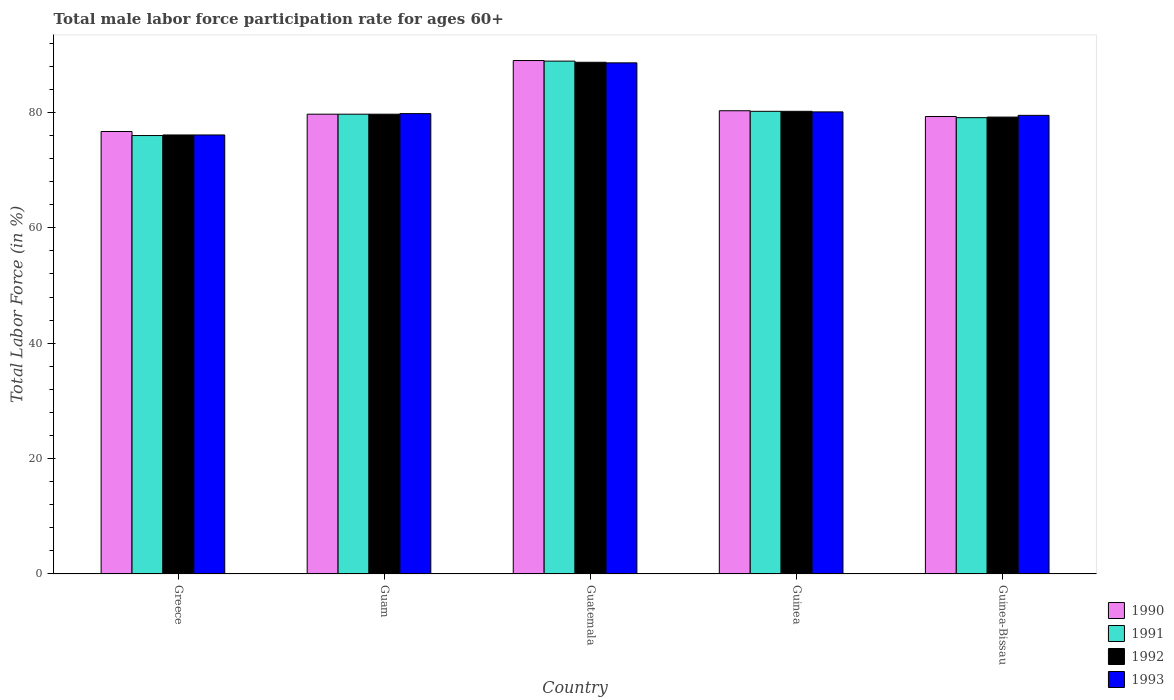How many different coloured bars are there?
Offer a terse response. 4. Are the number of bars per tick equal to the number of legend labels?
Your answer should be very brief. Yes. What is the label of the 5th group of bars from the left?
Give a very brief answer. Guinea-Bissau. What is the male labor force participation rate in 1992 in Guinea-Bissau?
Ensure brevity in your answer.  79.2. Across all countries, what is the maximum male labor force participation rate in 1991?
Provide a short and direct response. 88.9. Across all countries, what is the minimum male labor force participation rate in 1993?
Your answer should be compact. 76.1. In which country was the male labor force participation rate in 1990 maximum?
Offer a very short reply. Guatemala. In which country was the male labor force participation rate in 1990 minimum?
Provide a short and direct response. Greece. What is the total male labor force participation rate in 1992 in the graph?
Your answer should be very brief. 403.9. What is the difference between the male labor force participation rate in 1992 in Greece and that in Guinea-Bissau?
Your answer should be very brief. -3.1. What is the difference between the male labor force participation rate in 1991 in Greece and the male labor force participation rate in 1992 in Guinea-Bissau?
Make the answer very short. -3.2. What is the difference between the male labor force participation rate of/in 1993 and male labor force participation rate of/in 1991 in Guatemala?
Ensure brevity in your answer.  -0.3. What is the ratio of the male labor force participation rate in 1993 in Greece to that in Guinea?
Give a very brief answer. 0.95. Is the male labor force participation rate in 1993 in Guatemala less than that in Guinea?
Offer a very short reply. No. What is the difference between the highest and the second highest male labor force participation rate in 1991?
Ensure brevity in your answer.  8.7. What is the difference between the highest and the lowest male labor force participation rate in 1993?
Your answer should be very brief. 12.5. Is the sum of the male labor force participation rate in 1993 in Greece and Guinea-Bissau greater than the maximum male labor force participation rate in 1991 across all countries?
Make the answer very short. Yes. Is it the case that in every country, the sum of the male labor force participation rate in 1990 and male labor force participation rate in 1992 is greater than the sum of male labor force participation rate in 1993 and male labor force participation rate in 1991?
Your response must be concise. No. How many bars are there?
Provide a short and direct response. 20. How many countries are there in the graph?
Ensure brevity in your answer.  5. How are the legend labels stacked?
Offer a very short reply. Vertical. What is the title of the graph?
Offer a very short reply. Total male labor force participation rate for ages 60+. Does "1963" appear as one of the legend labels in the graph?
Keep it short and to the point. No. What is the label or title of the X-axis?
Ensure brevity in your answer.  Country. What is the label or title of the Y-axis?
Offer a very short reply. Total Labor Force (in %). What is the Total Labor Force (in %) of 1990 in Greece?
Your response must be concise. 76.7. What is the Total Labor Force (in %) in 1992 in Greece?
Give a very brief answer. 76.1. What is the Total Labor Force (in %) in 1993 in Greece?
Give a very brief answer. 76.1. What is the Total Labor Force (in %) in 1990 in Guam?
Give a very brief answer. 79.7. What is the Total Labor Force (in %) of 1991 in Guam?
Provide a succinct answer. 79.7. What is the Total Labor Force (in %) of 1992 in Guam?
Make the answer very short. 79.7. What is the Total Labor Force (in %) of 1993 in Guam?
Your response must be concise. 79.8. What is the Total Labor Force (in %) in 1990 in Guatemala?
Your answer should be very brief. 89. What is the Total Labor Force (in %) of 1991 in Guatemala?
Your response must be concise. 88.9. What is the Total Labor Force (in %) of 1992 in Guatemala?
Keep it short and to the point. 88.7. What is the Total Labor Force (in %) in 1993 in Guatemala?
Keep it short and to the point. 88.6. What is the Total Labor Force (in %) of 1990 in Guinea?
Provide a succinct answer. 80.3. What is the Total Labor Force (in %) of 1991 in Guinea?
Your answer should be compact. 80.2. What is the Total Labor Force (in %) of 1992 in Guinea?
Your response must be concise. 80.2. What is the Total Labor Force (in %) in 1993 in Guinea?
Your answer should be very brief. 80.1. What is the Total Labor Force (in %) in 1990 in Guinea-Bissau?
Make the answer very short. 79.3. What is the Total Labor Force (in %) of 1991 in Guinea-Bissau?
Ensure brevity in your answer.  79.1. What is the Total Labor Force (in %) in 1992 in Guinea-Bissau?
Your answer should be very brief. 79.2. What is the Total Labor Force (in %) of 1993 in Guinea-Bissau?
Your answer should be very brief. 79.5. Across all countries, what is the maximum Total Labor Force (in %) in 1990?
Offer a terse response. 89. Across all countries, what is the maximum Total Labor Force (in %) of 1991?
Offer a very short reply. 88.9. Across all countries, what is the maximum Total Labor Force (in %) in 1992?
Provide a succinct answer. 88.7. Across all countries, what is the maximum Total Labor Force (in %) in 1993?
Offer a terse response. 88.6. Across all countries, what is the minimum Total Labor Force (in %) of 1990?
Provide a succinct answer. 76.7. Across all countries, what is the minimum Total Labor Force (in %) in 1992?
Ensure brevity in your answer.  76.1. Across all countries, what is the minimum Total Labor Force (in %) of 1993?
Provide a short and direct response. 76.1. What is the total Total Labor Force (in %) in 1990 in the graph?
Offer a terse response. 405. What is the total Total Labor Force (in %) in 1991 in the graph?
Provide a short and direct response. 403.9. What is the total Total Labor Force (in %) in 1992 in the graph?
Give a very brief answer. 403.9. What is the total Total Labor Force (in %) of 1993 in the graph?
Keep it short and to the point. 404.1. What is the difference between the Total Labor Force (in %) of 1991 in Greece and that in Guam?
Give a very brief answer. -3.7. What is the difference between the Total Labor Force (in %) of 1993 in Greece and that in Guam?
Make the answer very short. -3.7. What is the difference between the Total Labor Force (in %) of 1992 in Greece and that in Guatemala?
Keep it short and to the point. -12.6. What is the difference between the Total Labor Force (in %) of 1993 in Greece and that in Guatemala?
Your response must be concise. -12.5. What is the difference between the Total Labor Force (in %) in 1990 in Greece and that in Guinea?
Offer a terse response. -3.6. What is the difference between the Total Labor Force (in %) in 1992 in Greece and that in Guinea?
Offer a terse response. -4.1. What is the difference between the Total Labor Force (in %) of 1990 in Greece and that in Guinea-Bissau?
Keep it short and to the point. -2.6. What is the difference between the Total Labor Force (in %) in 1993 in Greece and that in Guinea-Bissau?
Provide a succinct answer. -3.4. What is the difference between the Total Labor Force (in %) of 1991 in Guam and that in Guatemala?
Your response must be concise. -9.2. What is the difference between the Total Labor Force (in %) in 1992 in Guam and that in Guatemala?
Provide a succinct answer. -9. What is the difference between the Total Labor Force (in %) of 1993 in Guam and that in Guatemala?
Keep it short and to the point. -8.8. What is the difference between the Total Labor Force (in %) of 1990 in Guam and that in Guinea?
Your answer should be very brief. -0.6. What is the difference between the Total Labor Force (in %) of 1991 in Guam and that in Guinea?
Provide a short and direct response. -0.5. What is the difference between the Total Labor Force (in %) of 1992 in Guam and that in Guinea?
Give a very brief answer. -0.5. What is the difference between the Total Labor Force (in %) in 1993 in Guam and that in Guinea?
Give a very brief answer. -0.3. What is the difference between the Total Labor Force (in %) in 1992 in Guam and that in Guinea-Bissau?
Your answer should be very brief. 0.5. What is the difference between the Total Labor Force (in %) of 1993 in Guam and that in Guinea-Bissau?
Offer a terse response. 0.3. What is the difference between the Total Labor Force (in %) in 1990 in Guatemala and that in Guinea?
Your response must be concise. 8.7. What is the difference between the Total Labor Force (in %) in 1993 in Guatemala and that in Guinea?
Offer a terse response. 8.5. What is the difference between the Total Labor Force (in %) of 1990 in Guatemala and that in Guinea-Bissau?
Your answer should be very brief. 9.7. What is the difference between the Total Labor Force (in %) in 1991 in Guatemala and that in Guinea-Bissau?
Provide a short and direct response. 9.8. What is the difference between the Total Labor Force (in %) of 1992 in Guatemala and that in Guinea-Bissau?
Provide a short and direct response. 9.5. What is the difference between the Total Labor Force (in %) in 1990 in Guinea and that in Guinea-Bissau?
Your response must be concise. 1. What is the difference between the Total Labor Force (in %) in 1991 in Guinea and that in Guinea-Bissau?
Your answer should be compact. 1.1. What is the difference between the Total Labor Force (in %) in 1990 in Greece and the Total Labor Force (in %) in 1992 in Guam?
Give a very brief answer. -3. What is the difference between the Total Labor Force (in %) of 1990 in Greece and the Total Labor Force (in %) of 1991 in Guatemala?
Your answer should be very brief. -12.2. What is the difference between the Total Labor Force (in %) of 1991 in Greece and the Total Labor Force (in %) of 1993 in Guatemala?
Make the answer very short. -12.6. What is the difference between the Total Labor Force (in %) in 1990 in Greece and the Total Labor Force (in %) in 1991 in Guinea?
Ensure brevity in your answer.  -3.5. What is the difference between the Total Labor Force (in %) of 1992 in Greece and the Total Labor Force (in %) of 1993 in Guinea?
Offer a terse response. -4. What is the difference between the Total Labor Force (in %) of 1991 in Greece and the Total Labor Force (in %) of 1992 in Guinea-Bissau?
Your answer should be compact. -3.2. What is the difference between the Total Labor Force (in %) of 1991 in Greece and the Total Labor Force (in %) of 1993 in Guinea-Bissau?
Provide a succinct answer. -3.5. What is the difference between the Total Labor Force (in %) in 1992 in Greece and the Total Labor Force (in %) in 1993 in Guinea-Bissau?
Ensure brevity in your answer.  -3.4. What is the difference between the Total Labor Force (in %) in 1990 in Guam and the Total Labor Force (in %) in 1991 in Guatemala?
Provide a succinct answer. -9.2. What is the difference between the Total Labor Force (in %) in 1990 in Guam and the Total Labor Force (in %) in 1992 in Guatemala?
Your answer should be compact. -9. What is the difference between the Total Labor Force (in %) of 1990 in Guam and the Total Labor Force (in %) of 1991 in Guinea?
Your response must be concise. -0.5. What is the difference between the Total Labor Force (in %) in 1990 in Guam and the Total Labor Force (in %) in 1992 in Guinea?
Your response must be concise. -0.5. What is the difference between the Total Labor Force (in %) of 1990 in Guam and the Total Labor Force (in %) of 1993 in Guinea?
Your answer should be very brief. -0.4. What is the difference between the Total Labor Force (in %) in 1991 in Guam and the Total Labor Force (in %) in 1992 in Guinea?
Keep it short and to the point. -0.5. What is the difference between the Total Labor Force (in %) of 1992 in Guam and the Total Labor Force (in %) of 1993 in Guinea?
Give a very brief answer. -0.4. What is the difference between the Total Labor Force (in %) in 1990 in Guam and the Total Labor Force (in %) in 1992 in Guinea-Bissau?
Your response must be concise. 0.5. What is the difference between the Total Labor Force (in %) in 1991 in Guam and the Total Labor Force (in %) in 1992 in Guinea-Bissau?
Your response must be concise. 0.5. What is the difference between the Total Labor Force (in %) in 1991 in Guam and the Total Labor Force (in %) in 1993 in Guinea-Bissau?
Offer a very short reply. 0.2. What is the difference between the Total Labor Force (in %) of 1992 in Guam and the Total Labor Force (in %) of 1993 in Guinea-Bissau?
Make the answer very short. 0.2. What is the difference between the Total Labor Force (in %) in 1990 in Guatemala and the Total Labor Force (in %) in 1991 in Guinea?
Keep it short and to the point. 8.8. What is the difference between the Total Labor Force (in %) of 1990 in Guatemala and the Total Labor Force (in %) of 1993 in Guinea?
Your response must be concise. 8.9. What is the difference between the Total Labor Force (in %) in 1990 in Guatemala and the Total Labor Force (in %) in 1991 in Guinea-Bissau?
Provide a succinct answer. 9.9. What is the difference between the Total Labor Force (in %) in 1990 in Guatemala and the Total Labor Force (in %) in 1993 in Guinea-Bissau?
Ensure brevity in your answer.  9.5. What is the difference between the Total Labor Force (in %) of 1991 in Guatemala and the Total Labor Force (in %) of 1993 in Guinea-Bissau?
Provide a succinct answer. 9.4. What is the difference between the Total Labor Force (in %) of 1990 in Guinea and the Total Labor Force (in %) of 1992 in Guinea-Bissau?
Provide a short and direct response. 1.1. What is the difference between the Total Labor Force (in %) in 1990 in Guinea and the Total Labor Force (in %) in 1993 in Guinea-Bissau?
Give a very brief answer. 0.8. What is the average Total Labor Force (in %) in 1990 per country?
Provide a short and direct response. 81. What is the average Total Labor Force (in %) of 1991 per country?
Provide a short and direct response. 80.78. What is the average Total Labor Force (in %) in 1992 per country?
Make the answer very short. 80.78. What is the average Total Labor Force (in %) in 1993 per country?
Ensure brevity in your answer.  80.82. What is the difference between the Total Labor Force (in %) of 1990 and Total Labor Force (in %) of 1991 in Greece?
Give a very brief answer. 0.7. What is the difference between the Total Labor Force (in %) of 1990 and Total Labor Force (in %) of 1992 in Greece?
Offer a very short reply. 0.6. What is the difference between the Total Labor Force (in %) in 1990 and Total Labor Force (in %) in 1993 in Greece?
Keep it short and to the point. 0.6. What is the difference between the Total Labor Force (in %) of 1991 and Total Labor Force (in %) of 1992 in Greece?
Your answer should be very brief. -0.1. What is the difference between the Total Labor Force (in %) of 1991 and Total Labor Force (in %) of 1993 in Greece?
Offer a very short reply. -0.1. What is the difference between the Total Labor Force (in %) of 1992 and Total Labor Force (in %) of 1993 in Greece?
Make the answer very short. 0. What is the difference between the Total Labor Force (in %) of 1990 and Total Labor Force (in %) of 1991 in Guam?
Your response must be concise. 0. What is the difference between the Total Labor Force (in %) in 1990 and Total Labor Force (in %) in 1992 in Guam?
Keep it short and to the point. 0. What is the difference between the Total Labor Force (in %) in 1991 and Total Labor Force (in %) in 1992 in Guam?
Provide a succinct answer. 0. What is the difference between the Total Labor Force (in %) in 1990 and Total Labor Force (in %) in 1991 in Guatemala?
Your response must be concise. 0.1. What is the difference between the Total Labor Force (in %) in 1990 and Total Labor Force (in %) in 1991 in Guinea?
Provide a short and direct response. 0.1. What is the difference between the Total Labor Force (in %) of 1990 and Total Labor Force (in %) of 1992 in Guinea?
Ensure brevity in your answer.  0.1. What is the difference between the Total Labor Force (in %) of 1990 and Total Labor Force (in %) of 1991 in Guinea-Bissau?
Provide a short and direct response. 0.2. What is the difference between the Total Labor Force (in %) of 1990 and Total Labor Force (in %) of 1992 in Guinea-Bissau?
Offer a very short reply. 0.1. What is the difference between the Total Labor Force (in %) in 1990 and Total Labor Force (in %) in 1993 in Guinea-Bissau?
Keep it short and to the point. -0.2. What is the difference between the Total Labor Force (in %) in 1991 and Total Labor Force (in %) in 1992 in Guinea-Bissau?
Provide a short and direct response. -0.1. What is the difference between the Total Labor Force (in %) of 1991 and Total Labor Force (in %) of 1993 in Guinea-Bissau?
Offer a terse response. -0.4. What is the difference between the Total Labor Force (in %) of 1992 and Total Labor Force (in %) of 1993 in Guinea-Bissau?
Provide a short and direct response. -0.3. What is the ratio of the Total Labor Force (in %) of 1990 in Greece to that in Guam?
Give a very brief answer. 0.96. What is the ratio of the Total Labor Force (in %) of 1991 in Greece to that in Guam?
Keep it short and to the point. 0.95. What is the ratio of the Total Labor Force (in %) of 1992 in Greece to that in Guam?
Offer a very short reply. 0.95. What is the ratio of the Total Labor Force (in %) in 1993 in Greece to that in Guam?
Provide a succinct answer. 0.95. What is the ratio of the Total Labor Force (in %) of 1990 in Greece to that in Guatemala?
Give a very brief answer. 0.86. What is the ratio of the Total Labor Force (in %) in 1991 in Greece to that in Guatemala?
Ensure brevity in your answer.  0.85. What is the ratio of the Total Labor Force (in %) in 1992 in Greece to that in Guatemala?
Make the answer very short. 0.86. What is the ratio of the Total Labor Force (in %) in 1993 in Greece to that in Guatemala?
Provide a short and direct response. 0.86. What is the ratio of the Total Labor Force (in %) in 1990 in Greece to that in Guinea?
Your answer should be compact. 0.96. What is the ratio of the Total Labor Force (in %) in 1991 in Greece to that in Guinea?
Provide a short and direct response. 0.95. What is the ratio of the Total Labor Force (in %) in 1992 in Greece to that in Guinea?
Your answer should be very brief. 0.95. What is the ratio of the Total Labor Force (in %) in 1993 in Greece to that in Guinea?
Offer a very short reply. 0.95. What is the ratio of the Total Labor Force (in %) in 1990 in Greece to that in Guinea-Bissau?
Provide a succinct answer. 0.97. What is the ratio of the Total Labor Force (in %) of 1991 in Greece to that in Guinea-Bissau?
Ensure brevity in your answer.  0.96. What is the ratio of the Total Labor Force (in %) in 1992 in Greece to that in Guinea-Bissau?
Give a very brief answer. 0.96. What is the ratio of the Total Labor Force (in %) in 1993 in Greece to that in Guinea-Bissau?
Ensure brevity in your answer.  0.96. What is the ratio of the Total Labor Force (in %) of 1990 in Guam to that in Guatemala?
Offer a terse response. 0.9. What is the ratio of the Total Labor Force (in %) in 1991 in Guam to that in Guatemala?
Keep it short and to the point. 0.9. What is the ratio of the Total Labor Force (in %) in 1992 in Guam to that in Guatemala?
Offer a very short reply. 0.9. What is the ratio of the Total Labor Force (in %) in 1993 in Guam to that in Guatemala?
Make the answer very short. 0.9. What is the ratio of the Total Labor Force (in %) in 1990 in Guam to that in Guinea-Bissau?
Your answer should be compact. 1. What is the ratio of the Total Labor Force (in %) in 1991 in Guam to that in Guinea-Bissau?
Keep it short and to the point. 1.01. What is the ratio of the Total Labor Force (in %) of 1992 in Guam to that in Guinea-Bissau?
Offer a very short reply. 1.01. What is the ratio of the Total Labor Force (in %) in 1993 in Guam to that in Guinea-Bissau?
Give a very brief answer. 1. What is the ratio of the Total Labor Force (in %) of 1990 in Guatemala to that in Guinea?
Offer a very short reply. 1.11. What is the ratio of the Total Labor Force (in %) in 1991 in Guatemala to that in Guinea?
Your response must be concise. 1.11. What is the ratio of the Total Labor Force (in %) of 1992 in Guatemala to that in Guinea?
Offer a very short reply. 1.11. What is the ratio of the Total Labor Force (in %) in 1993 in Guatemala to that in Guinea?
Give a very brief answer. 1.11. What is the ratio of the Total Labor Force (in %) of 1990 in Guatemala to that in Guinea-Bissau?
Offer a very short reply. 1.12. What is the ratio of the Total Labor Force (in %) in 1991 in Guatemala to that in Guinea-Bissau?
Your answer should be compact. 1.12. What is the ratio of the Total Labor Force (in %) of 1992 in Guatemala to that in Guinea-Bissau?
Your response must be concise. 1.12. What is the ratio of the Total Labor Force (in %) of 1993 in Guatemala to that in Guinea-Bissau?
Your answer should be very brief. 1.11. What is the ratio of the Total Labor Force (in %) in 1990 in Guinea to that in Guinea-Bissau?
Give a very brief answer. 1.01. What is the ratio of the Total Labor Force (in %) in 1991 in Guinea to that in Guinea-Bissau?
Ensure brevity in your answer.  1.01. What is the ratio of the Total Labor Force (in %) in 1992 in Guinea to that in Guinea-Bissau?
Provide a short and direct response. 1.01. What is the ratio of the Total Labor Force (in %) of 1993 in Guinea to that in Guinea-Bissau?
Keep it short and to the point. 1.01. What is the difference between the highest and the second highest Total Labor Force (in %) in 1992?
Ensure brevity in your answer.  8.5. What is the difference between the highest and the lowest Total Labor Force (in %) of 1991?
Your answer should be very brief. 12.9. What is the difference between the highest and the lowest Total Labor Force (in %) of 1992?
Provide a short and direct response. 12.6. What is the difference between the highest and the lowest Total Labor Force (in %) of 1993?
Make the answer very short. 12.5. 